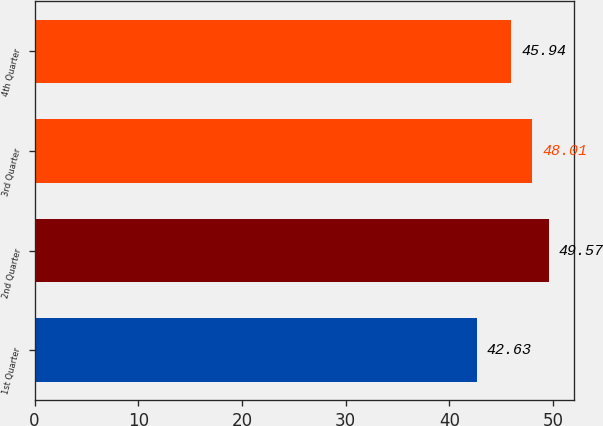<chart> <loc_0><loc_0><loc_500><loc_500><bar_chart><fcel>1st Quarter<fcel>2nd Quarter<fcel>3rd Quarter<fcel>4th Quarter<nl><fcel>42.63<fcel>49.57<fcel>48.01<fcel>45.94<nl></chart> 